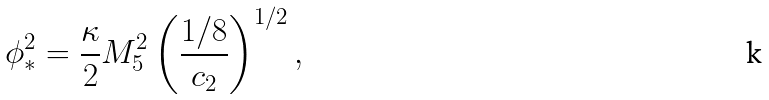<formula> <loc_0><loc_0><loc_500><loc_500>\phi _ { * } ^ { 2 } = \frac { \kappa } { 2 } M _ { 5 } ^ { 2 } \left ( \frac { 1 / 8 } { c _ { 2 } } \right ) ^ { 1 / 2 } ,</formula> 